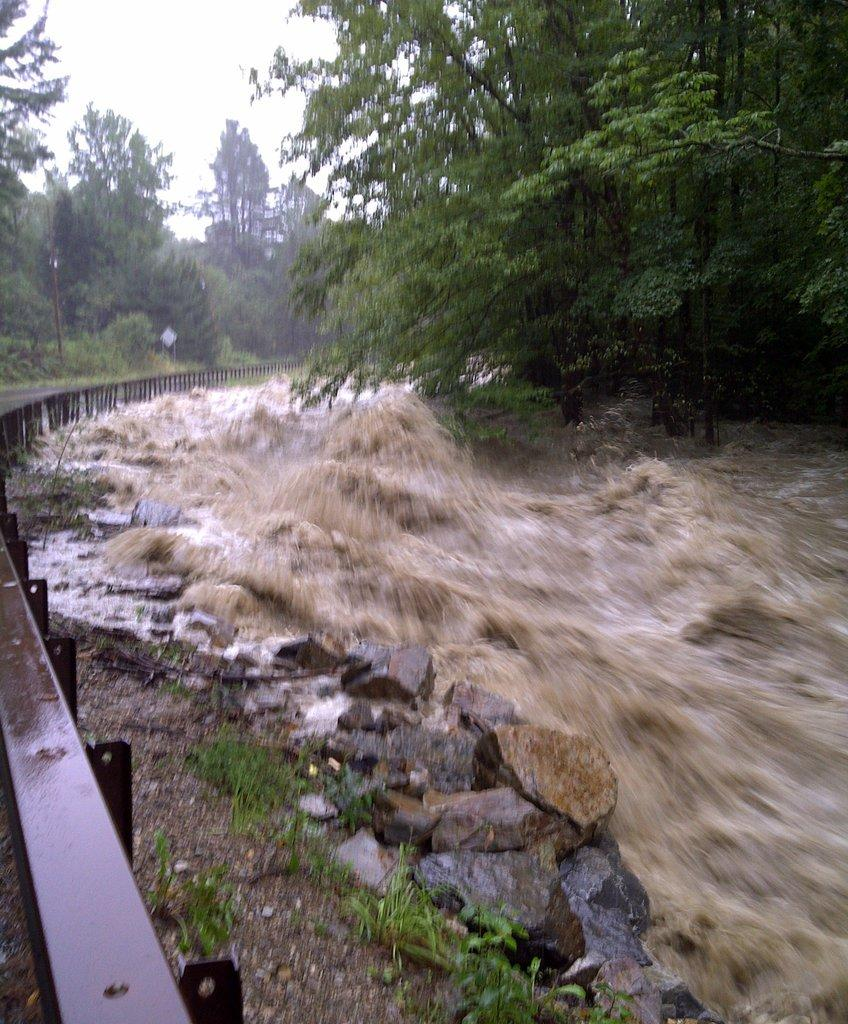What is the primary element in the image? There is water in the image. What other objects can be seen in the image? There are stones and a metal railing on the left side of the image. What can be seen in the background of the image? There is a group of trees and the sky visible in the background of the image. Where are the flowers being grown in the image? There are no flowers present in the image. What type of frame is used to hold the image? The provided facts do not mention a frame, as we are assuming that we are looking at the image directly. 